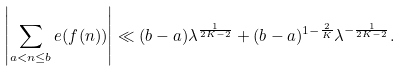<formula> <loc_0><loc_0><loc_500><loc_500>\left | \sum _ { a < n \leq b } e ( f ( n ) ) \right | \ll ( b - a ) \lambda ^ { \frac { 1 } { 2 K - 2 } } + ( b - a ) ^ { 1 - \frac { 2 } { K } } \lambda ^ { - \frac { 1 } { 2 K - 2 } } .</formula> 